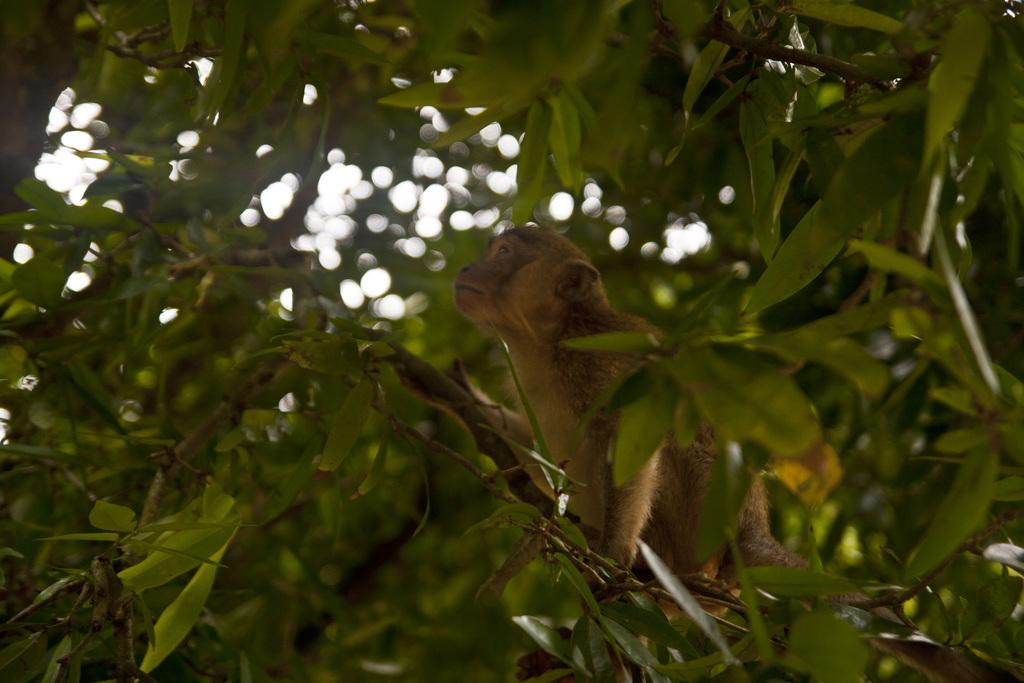What type of animal is in the image? There is a brown-colored monkey in the image. Where is the monkey located? The monkey is on a branch of a tree. What color are the leaves in the image? The leaves in the image are green-colored. How would you describe the overall clarity of the image? The image is slightly blurry in the background. What type of jeans is the monkey wearing in the image? The monkey is not wearing jeans in the image; it is a monkey and not a human. 